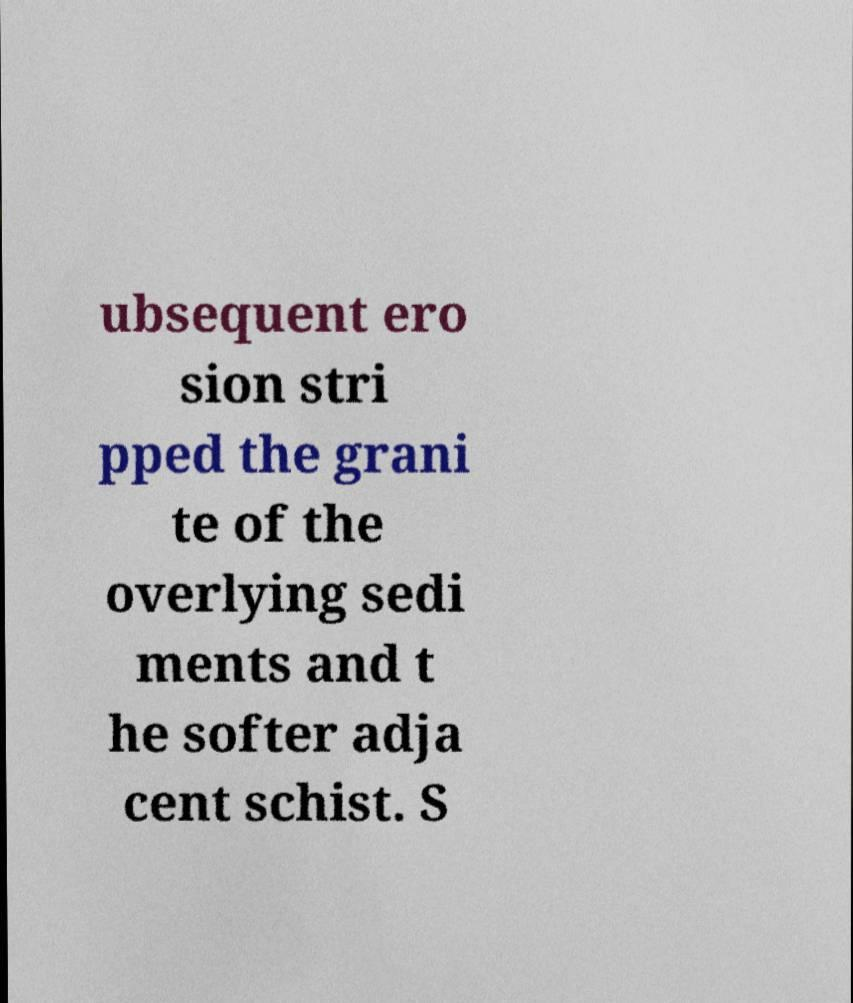Please read and relay the text visible in this image. What does it say? ubsequent ero sion stri pped the grani te of the overlying sedi ments and t he softer adja cent schist. S 